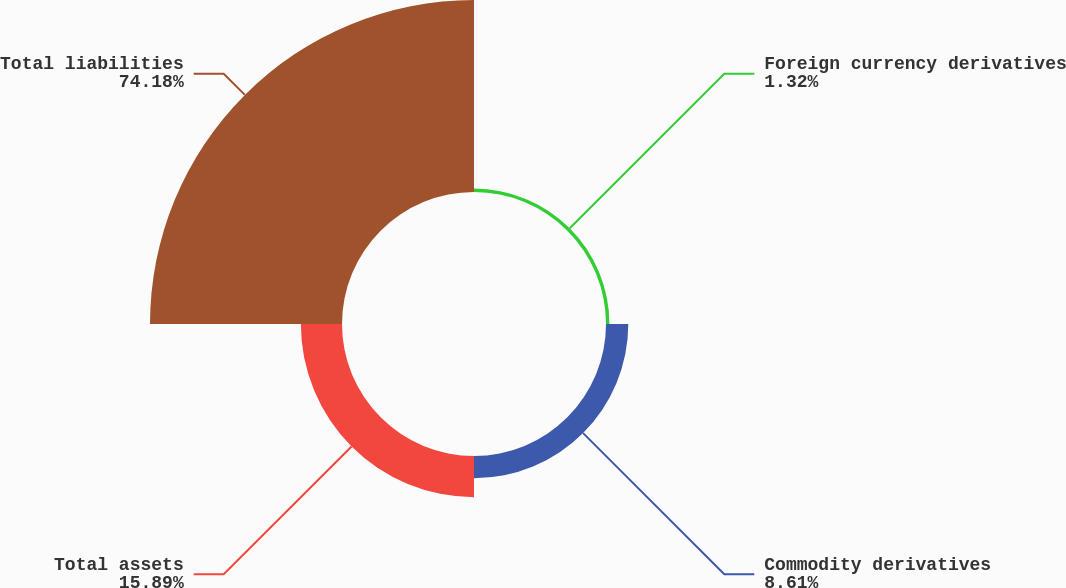Convert chart to OTSL. <chart><loc_0><loc_0><loc_500><loc_500><pie_chart><fcel>Foreign currency derivatives<fcel>Commodity derivatives<fcel>Total assets<fcel>Total liabilities<nl><fcel>1.32%<fcel>8.61%<fcel>15.89%<fcel>74.17%<nl></chart> 